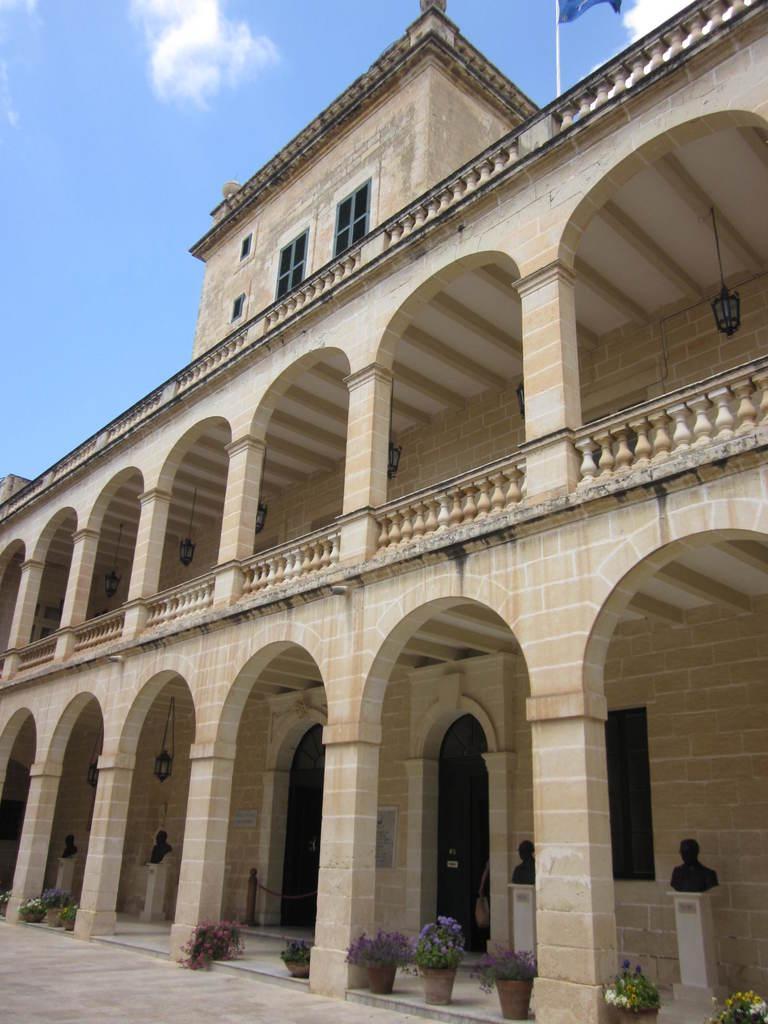Please provide a concise description of this image. In this image we can see a building with windows, pillars and the street lamps. We can also see the statues, a pole with a chain, some plants in the pots, the flag to a pole and the sky which looks cloudy. 